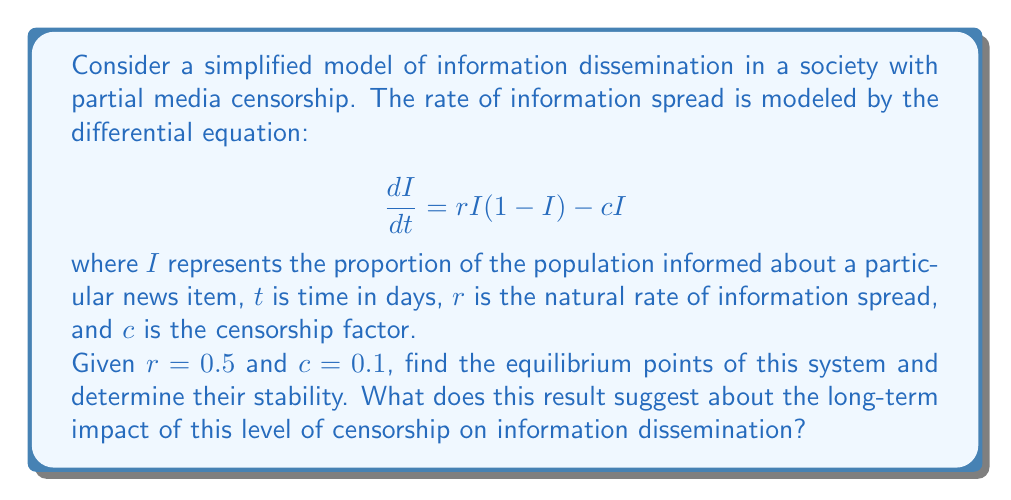Provide a solution to this math problem. To solve this problem, we'll follow these steps:

1) Find the equilibrium points by setting $\frac{dI}{dt} = 0$:

   $$ 0 = rI(1-I) - cI $$
   $$ 0 = 0.5I(1-I) - 0.1I $$
   $$ 0 = 0.5I - 0.5I^2 - 0.1I $$
   $$ 0 = I(0.4 - 0.5I) $$

2) Solve this equation:
   
   $I = 0$ or $0.4 - 0.5I = 0$
   
   $I = 0$ or $I = 0.8$

   So, the equilibrium points are $I_1 = 0$ and $I_2 = 0.8$

3) To determine stability, we evaluate the derivative of $\frac{dI}{dt}$ with respect to $I$ at each equilibrium point:

   $$ \frac{d}{dI}(\frac{dI}{dt}) = r(1-2I) - c = 0.5(1-2I) - 0.1 $$

   At $I_1 = 0$: $0.5(1-2(0)) - 0.1 = 0.4 > 0$, so this is an unstable equilibrium.
   At $I_2 = 0.8$: $0.5(1-2(0.8)) - 0.1 = -0.4 < 0$, so this is a stable equilibrium.

4) Interpretation: The stable equilibrium at $I_2 = 0.8$ suggests that, in the long term, about 80% of the population will become informed about the news item, despite the censorship efforts. The unstable equilibrium at $I_1 = 0$ indicates that if any information spreads at all, it will tend towards the stable equilibrium.
Answer: Equilibrium points: $I_1 = 0$ (unstable) and $I_2 = 0.8$ (stable). This suggests that despite censorship, information will likely spread to 80% of the population in the long term. 